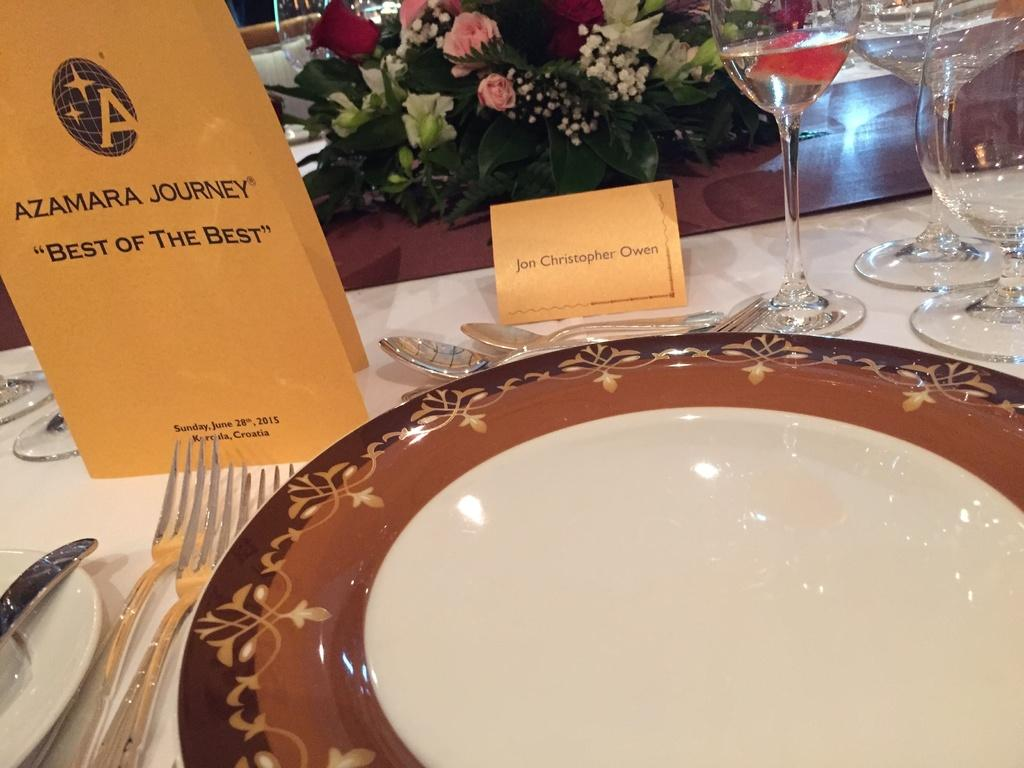What is located in the center of the image? There is a plate in the center of the image. What utensils can be seen in the image? There are forks, spoons, and glasses in the image. What decorative items are present in the image? There are plastic flowers in the image. What is the name of the paper cover in the image? The paper cover is named "Azamara journey." What type of horse is depicted on the paper cover in the image? There is no horse depicted on the paper cover in the image; it is named "Azamara journey." What riddle can be solved by looking at the utensils in the image? There is no riddle associated with the utensils in the image; they are simply utensils for eating. 